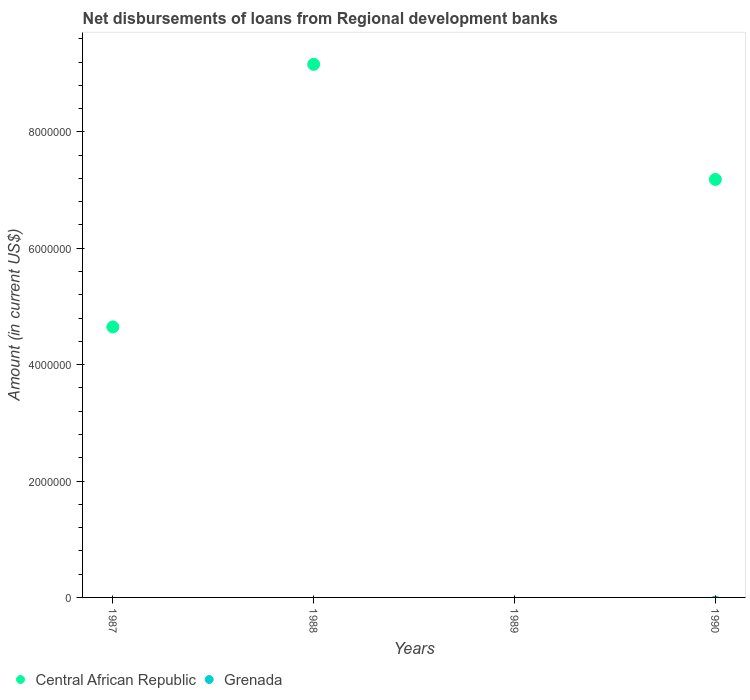Across all years, what is the maximum amount of disbursements of loans from regional development banks in Central African Republic?
Your answer should be compact. 9.16e+06. Across all years, what is the minimum amount of disbursements of loans from regional development banks in Grenada?
Your answer should be compact. 0. In which year was the amount of disbursements of loans from regional development banks in Central African Republic maximum?
Offer a very short reply. 1988. What is the difference between the amount of disbursements of loans from regional development banks in Central African Republic in 1987 and that in 1990?
Your answer should be compact. -2.54e+06. What is the difference between the amount of disbursements of loans from regional development banks in Grenada in 1989 and the amount of disbursements of loans from regional development banks in Central African Republic in 1987?
Keep it short and to the point. -4.65e+06. What is the average amount of disbursements of loans from regional development banks in Central African Republic per year?
Offer a terse response. 5.25e+06. What is the ratio of the amount of disbursements of loans from regional development banks in Central African Republic in 1988 to that in 1990?
Ensure brevity in your answer.  1.28. Is the amount of disbursements of loans from regional development banks in Central African Republic in 1987 less than that in 1988?
Keep it short and to the point. Yes. What is the difference between the highest and the second highest amount of disbursements of loans from regional development banks in Central African Republic?
Offer a terse response. 1.98e+06. What is the difference between the highest and the lowest amount of disbursements of loans from regional development banks in Central African Republic?
Ensure brevity in your answer.  9.16e+06. In how many years, is the amount of disbursements of loans from regional development banks in Grenada greater than the average amount of disbursements of loans from regional development banks in Grenada taken over all years?
Your answer should be compact. 0. Does the amount of disbursements of loans from regional development banks in Grenada monotonically increase over the years?
Offer a terse response. Yes. Are the values on the major ticks of Y-axis written in scientific E-notation?
Your answer should be very brief. No. Does the graph contain grids?
Your answer should be very brief. No. Where does the legend appear in the graph?
Your answer should be very brief. Bottom left. How many legend labels are there?
Make the answer very short. 2. What is the title of the graph?
Offer a very short reply. Net disbursements of loans from Regional development banks. Does "Iran" appear as one of the legend labels in the graph?
Offer a very short reply. No. What is the label or title of the X-axis?
Offer a very short reply. Years. What is the Amount (in current US$) of Central African Republic in 1987?
Give a very brief answer. 4.65e+06. What is the Amount (in current US$) of Central African Republic in 1988?
Ensure brevity in your answer.  9.16e+06. What is the Amount (in current US$) in Grenada in 1989?
Provide a short and direct response. 0. What is the Amount (in current US$) of Central African Republic in 1990?
Offer a very short reply. 7.18e+06. Across all years, what is the maximum Amount (in current US$) in Central African Republic?
Offer a terse response. 9.16e+06. What is the total Amount (in current US$) of Central African Republic in the graph?
Ensure brevity in your answer.  2.10e+07. What is the total Amount (in current US$) of Grenada in the graph?
Your answer should be very brief. 0. What is the difference between the Amount (in current US$) in Central African Republic in 1987 and that in 1988?
Provide a short and direct response. -4.51e+06. What is the difference between the Amount (in current US$) in Central African Republic in 1987 and that in 1990?
Your answer should be compact. -2.54e+06. What is the difference between the Amount (in current US$) in Central African Republic in 1988 and that in 1990?
Provide a succinct answer. 1.98e+06. What is the average Amount (in current US$) in Central African Republic per year?
Provide a succinct answer. 5.25e+06. What is the average Amount (in current US$) in Grenada per year?
Your answer should be compact. 0. What is the ratio of the Amount (in current US$) in Central African Republic in 1987 to that in 1988?
Make the answer very short. 0.51. What is the ratio of the Amount (in current US$) in Central African Republic in 1987 to that in 1990?
Keep it short and to the point. 0.65. What is the ratio of the Amount (in current US$) of Central African Republic in 1988 to that in 1990?
Your response must be concise. 1.28. What is the difference between the highest and the second highest Amount (in current US$) in Central African Republic?
Your response must be concise. 1.98e+06. What is the difference between the highest and the lowest Amount (in current US$) in Central African Republic?
Keep it short and to the point. 9.16e+06. 